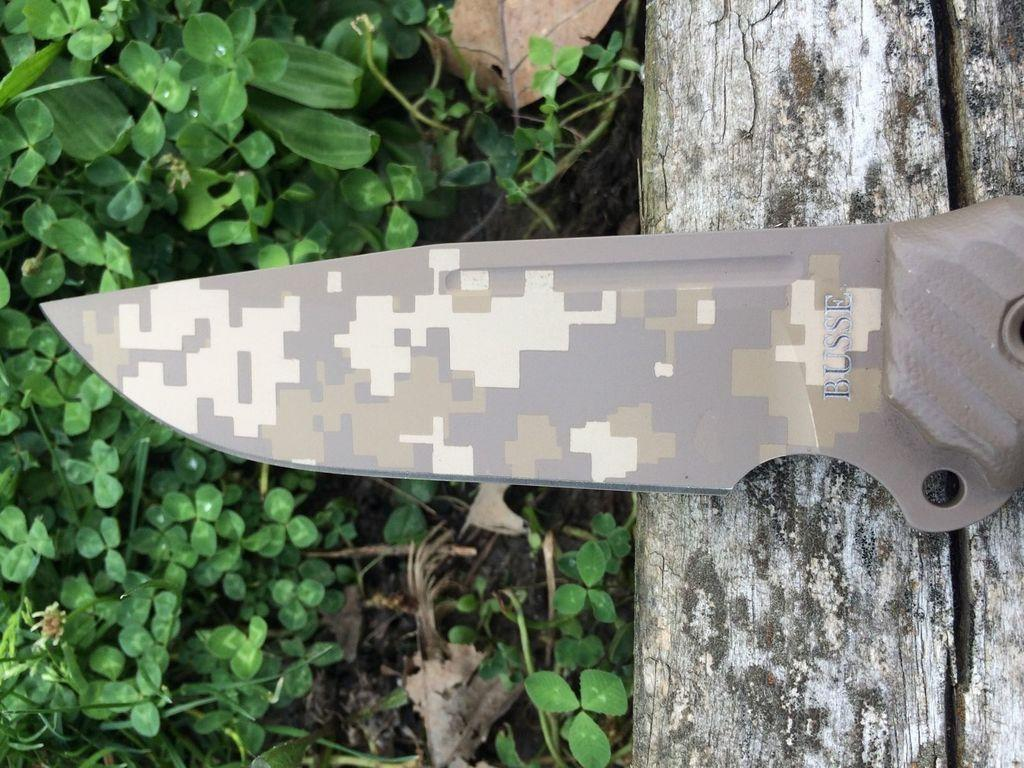What object is placed on a surface in the image? There is a knife placed on a surface in the image. What can be seen in the background of the image? There is a group of leaves in the background of the image. What team is responsible for maintaining the watch in the image? There is no watch present in the image, so it is not possible to determine which team might be responsible for maintaining it. 